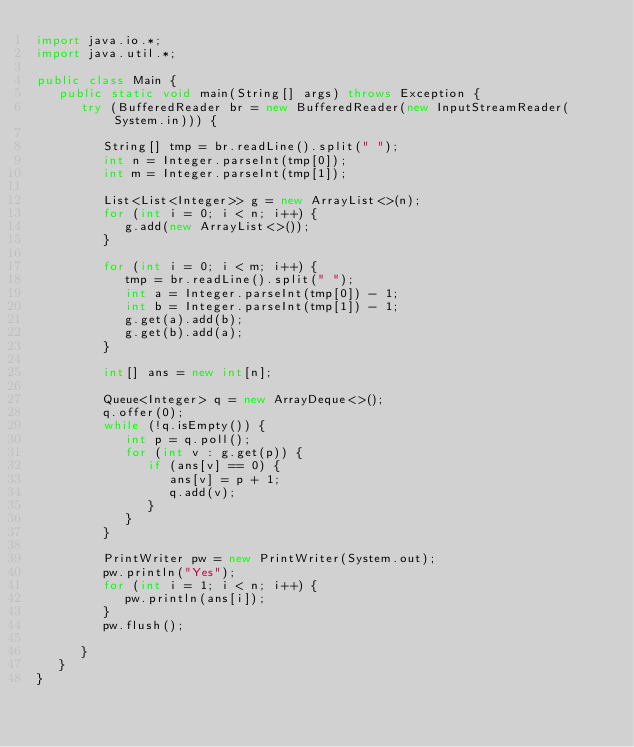<code> <loc_0><loc_0><loc_500><loc_500><_Java_>import java.io.*;
import java.util.*;

public class Main {
   public static void main(String[] args) throws Exception {
      try (BufferedReader br = new BufferedReader(new InputStreamReader(System.in))) {

         String[] tmp = br.readLine().split(" ");
         int n = Integer.parseInt(tmp[0]);
         int m = Integer.parseInt(tmp[1]);

         List<List<Integer>> g = new ArrayList<>(n);
         for (int i = 0; i < n; i++) {
            g.add(new ArrayList<>());
         }

         for (int i = 0; i < m; i++) {
            tmp = br.readLine().split(" ");
            int a = Integer.parseInt(tmp[0]) - 1;
            int b = Integer.parseInt(tmp[1]) - 1;
            g.get(a).add(b);
            g.get(b).add(a);
         }

         int[] ans = new int[n];

         Queue<Integer> q = new ArrayDeque<>();
         q.offer(0);
         while (!q.isEmpty()) {
            int p = q.poll();
            for (int v : g.get(p)) {
               if (ans[v] == 0) {
                  ans[v] = p + 1;
                  q.add(v);
               }
            }
         }

         PrintWriter pw = new PrintWriter(System.out);
         pw.println("Yes");
         for (int i = 1; i < n; i++) {
            pw.println(ans[i]);
         }
         pw.flush();

      }
   }
}</code> 